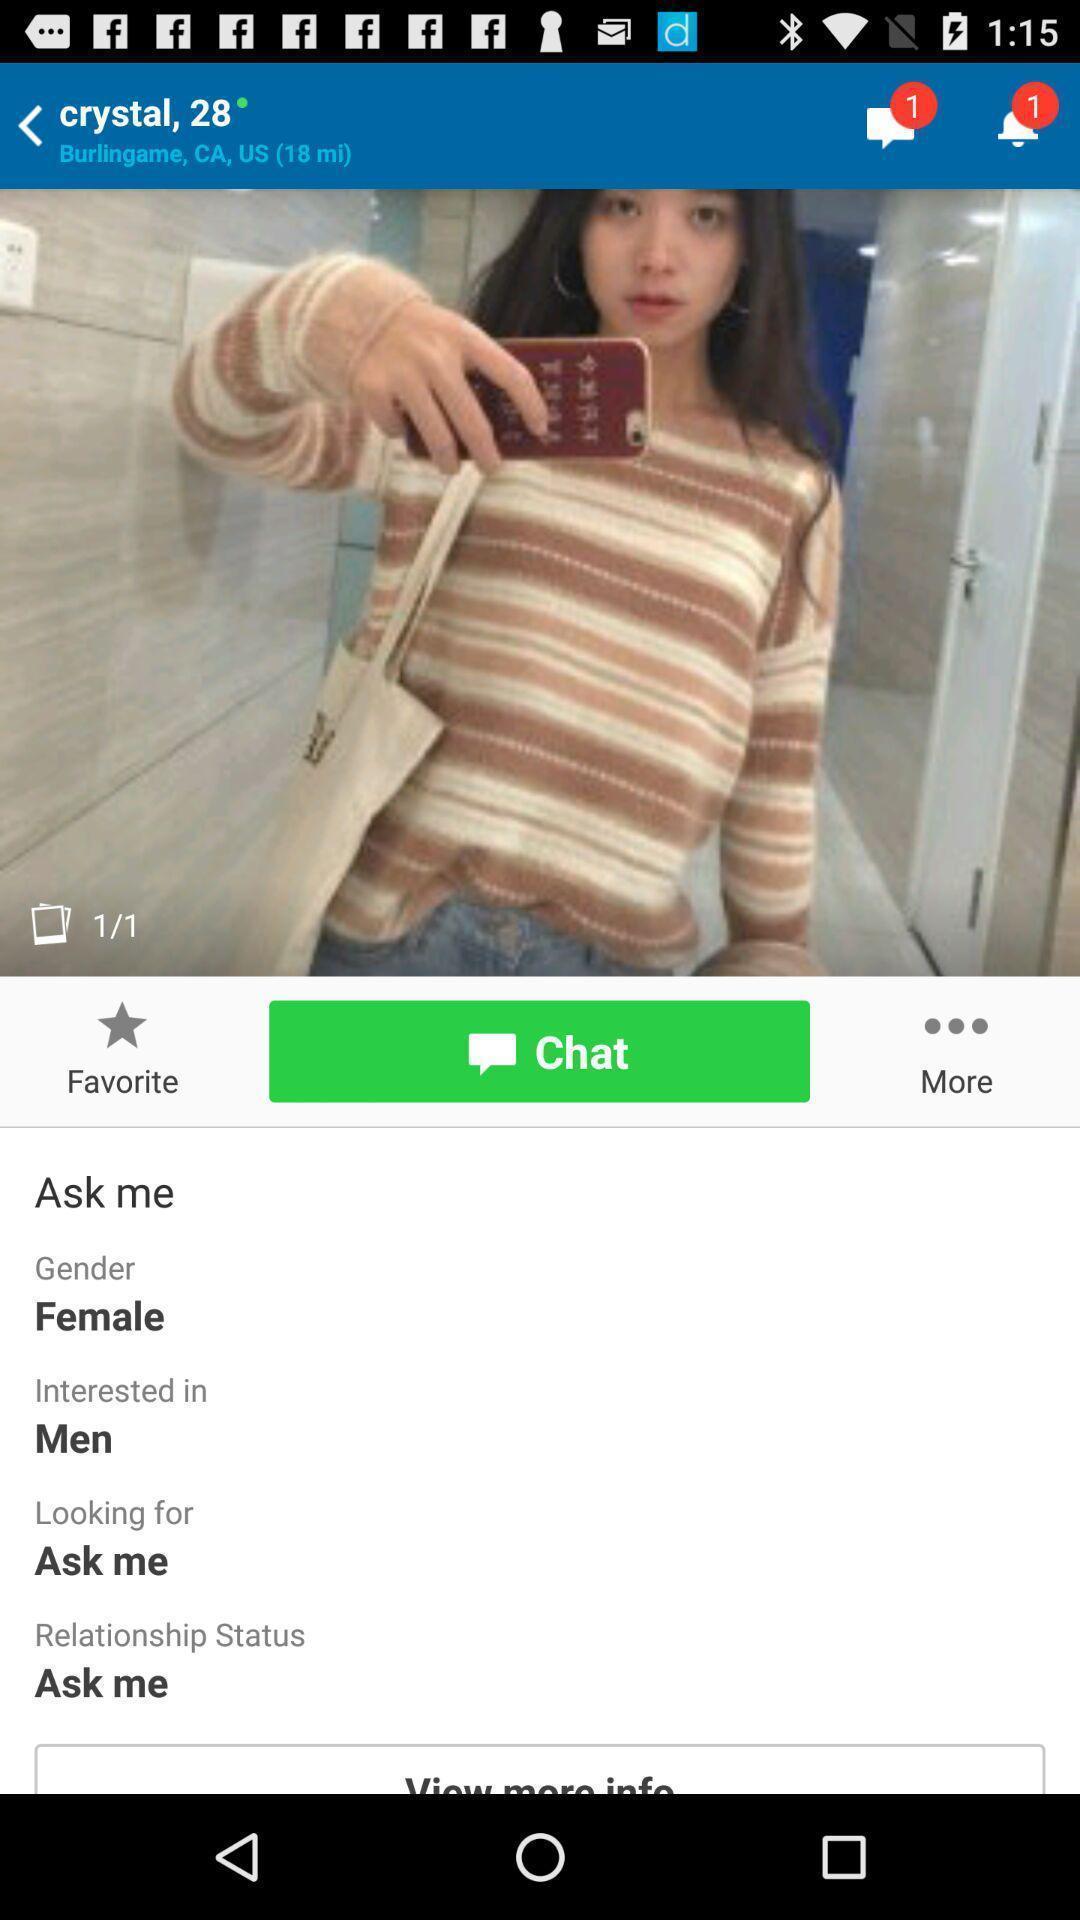Explain what's happening in this screen capture. Screen shows different options in a social app. 